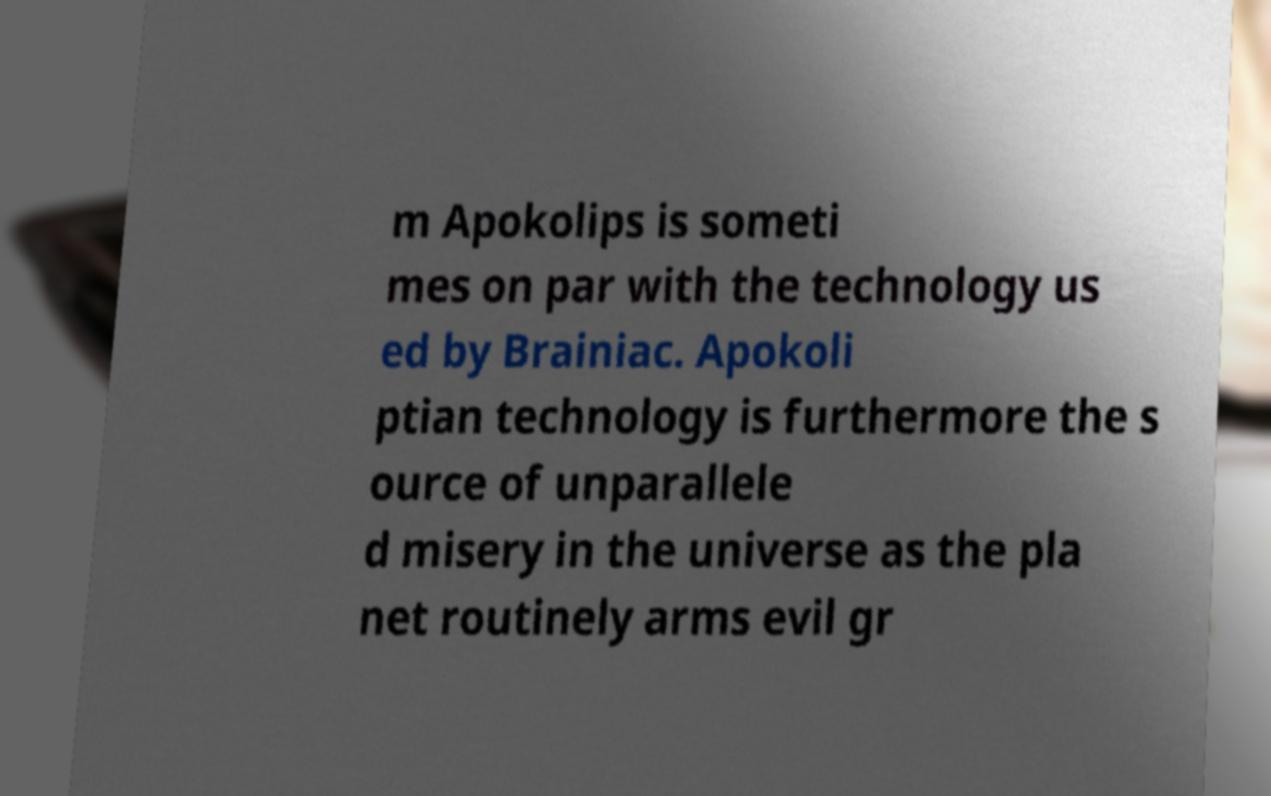What messages or text are displayed in this image? I need them in a readable, typed format. m Apokolips is someti mes on par with the technology us ed by Brainiac. Apokoli ptian technology is furthermore the s ource of unparallele d misery in the universe as the pla net routinely arms evil gr 